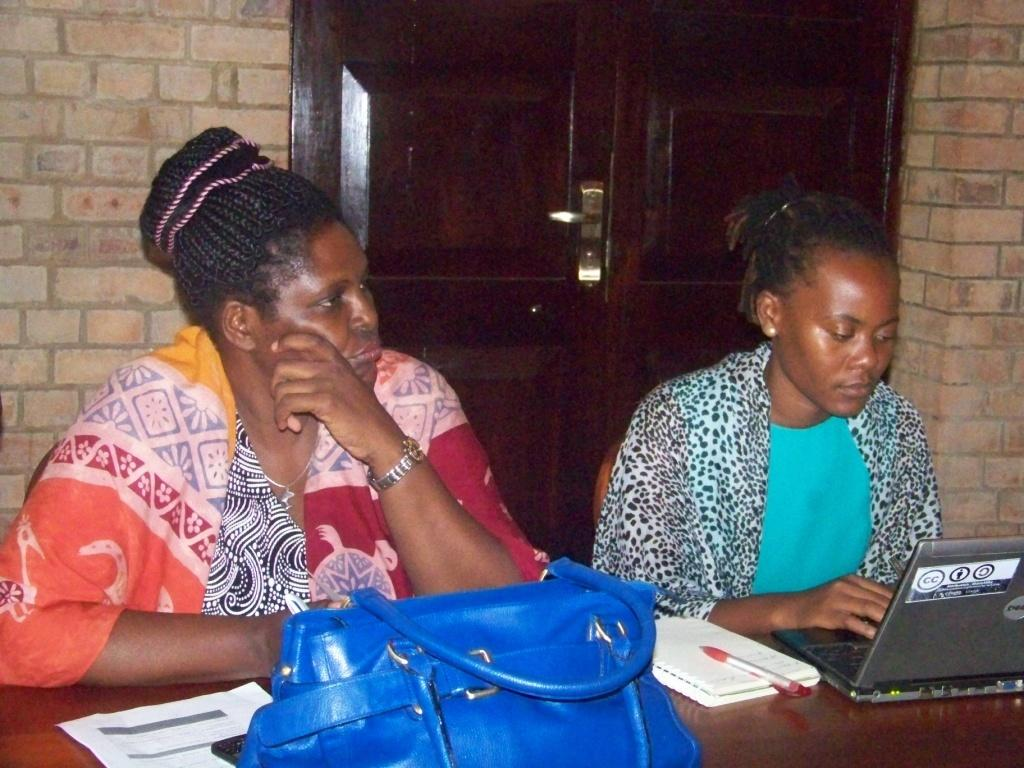How many women are in the image? There are two women in the image. What are the women doing in the image? The women are sitting in chairs. What is in front of the chairs? There is a table in front of the chairs. What items can be seen on the table? There are papers, a mobile, a bag, and a laptop on the table. What can be seen in the background of the image? There is a wall and a door in the background of the image. How many kittens are playing with a calculator on the table in the image? There are no kittens or calculators present in the image. What is the distance between the two women in the image? The distance between the two women cannot be determined from the image, as it only shows them sitting in chairs. 